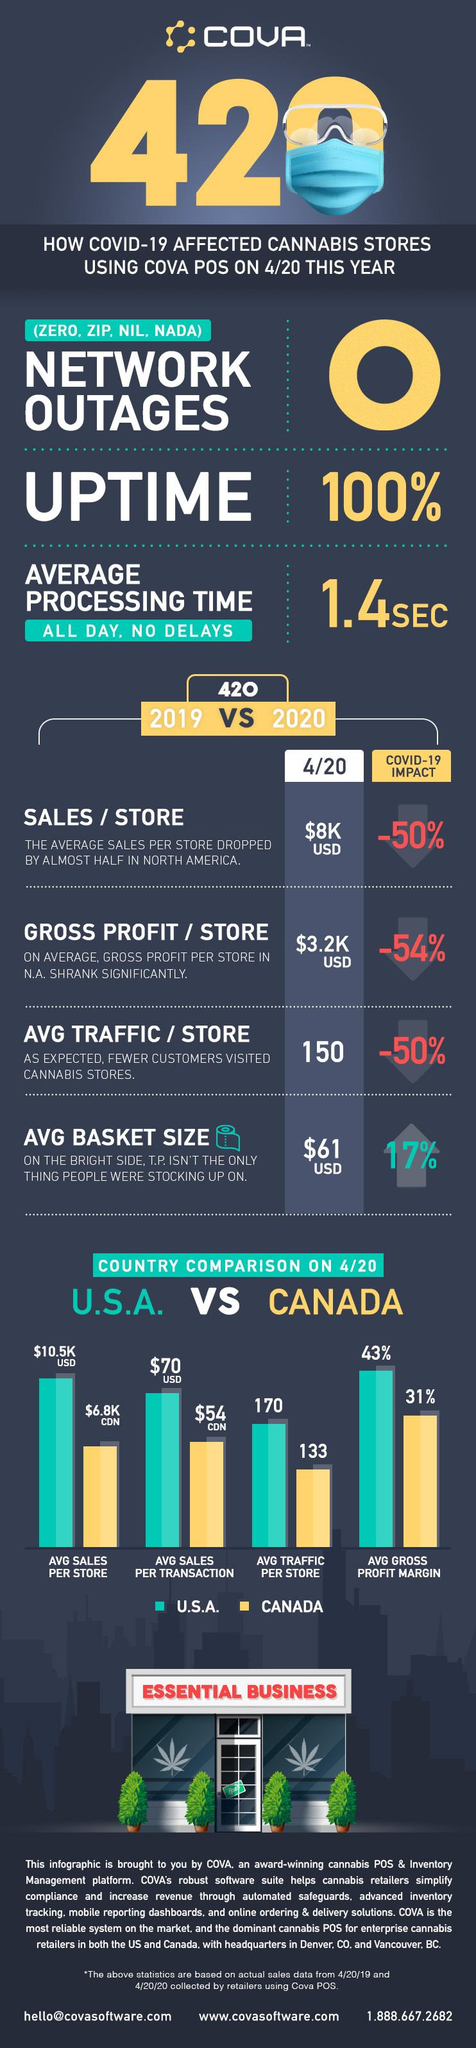Specify some key components in this picture. The average gross profit margin between the United States and Canada differs by 12%. The United States of America has a higher average traffic per store than Canada. 